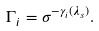<formula> <loc_0><loc_0><loc_500><loc_500>\Gamma _ { i } = \sigma ^ { - \gamma _ { i } ( \lambda _ { s } ) } .</formula> 